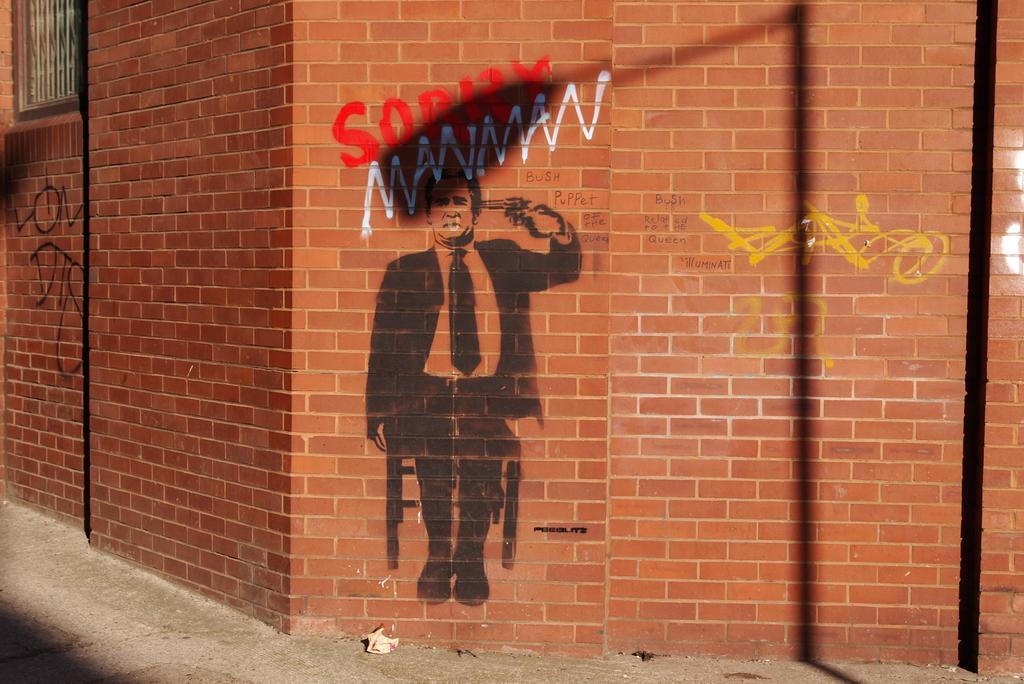How would you summarize this image in a sentence or two? In this picture I can see paintings on the wall. 